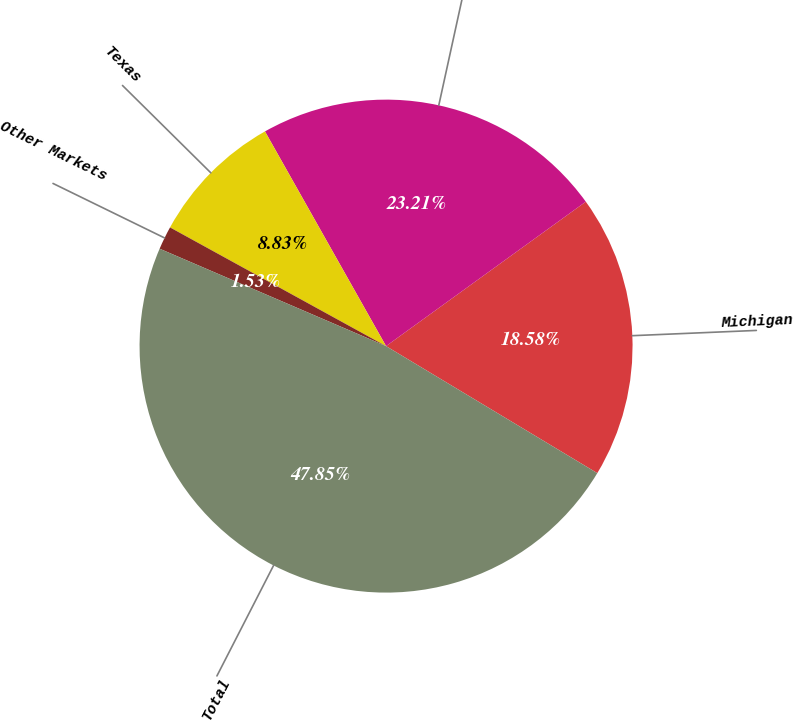<chart> <loc_0><loc_0><loc_500><loc_500><pie_chart><fcel>Michigan<fcel>California<fcel>Texas<fcel>Other Markets<fcel>Total<nl><fcel>18.58%<fcel>23.21%<fcel>8.83%<fcel>1.53%<fcel>47.85%<nl></chart> 